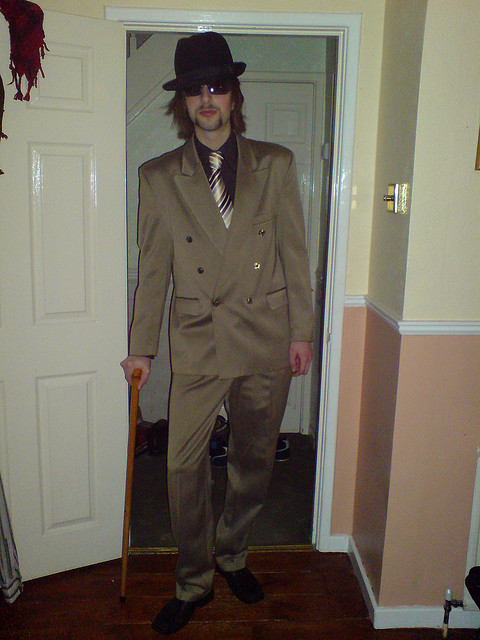<image>What branch is he? It is ambiguous what branch he is. What branch is he? I don't know what branch he is. It is unclear from the given information. 